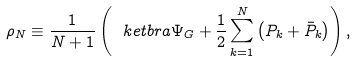Convert formula to latex. <formula><loc_0><loc_0><loc_500><loc_500>\rho _ { N } \equiv \frac { 1 } { N + 1 } \left ( \ k e t b r a { \Psi _ { G } } + \frac { 1 } { 2 } \sum _ { k = 1 } ^ { N } \left ( P _ { k } + \bar { P } _ { k } \right ) \right ) ,</formula> 